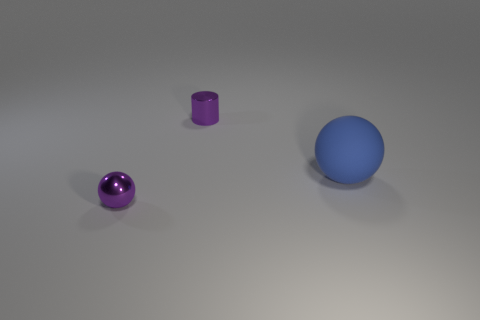Add 2 shiny cylinders. How many objects exist? 5 Subtract all balls. How many objects are left? 1 Subtract 0 yellow cylinders. How many objects are left? 3 Subtract all red spheres. Subtract all cyan cubes. How many spheres are left? 2 Subtract all cyan cylinders. How many yellow spheres are left? 0 Subtract all large green rubber balls. Subtract all big blue spheres. How many objects are left? 2 Add 2 shiny things. How many shiny things are left? 4 Add 2 metallic balls. How many metallic balls exist? 3 Subtract all purple spheres. How many spheres are left? 1 